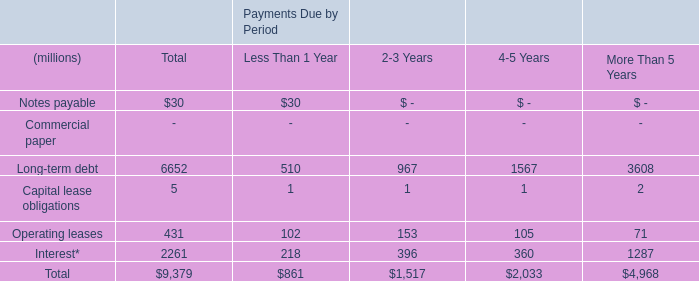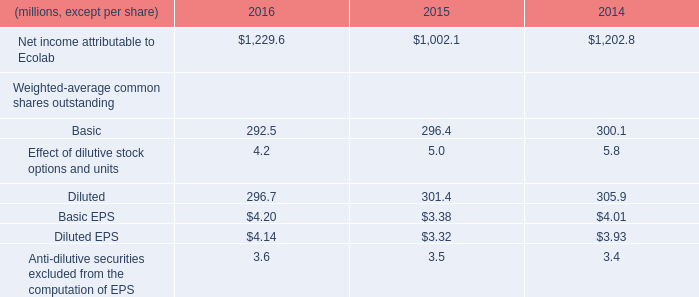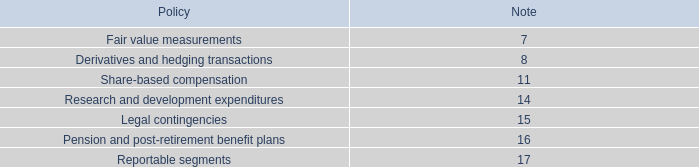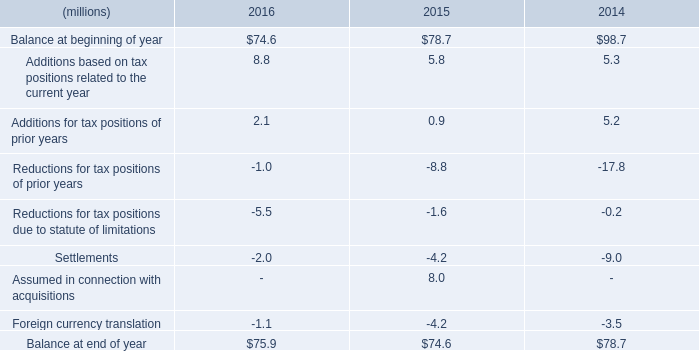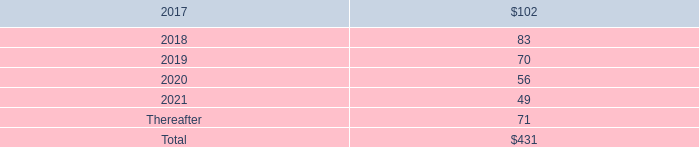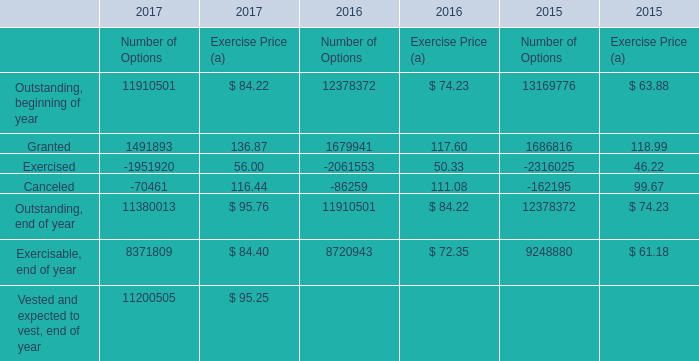What's the increasing rate of Granted in 2017 for Exercise Price? 
Computations: ((136.87 - 117.60) / 117.60)
Answer: 0.16386. 